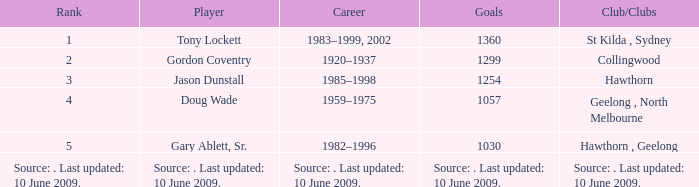What is the rank of player Jason Dunstall? 3.0. 